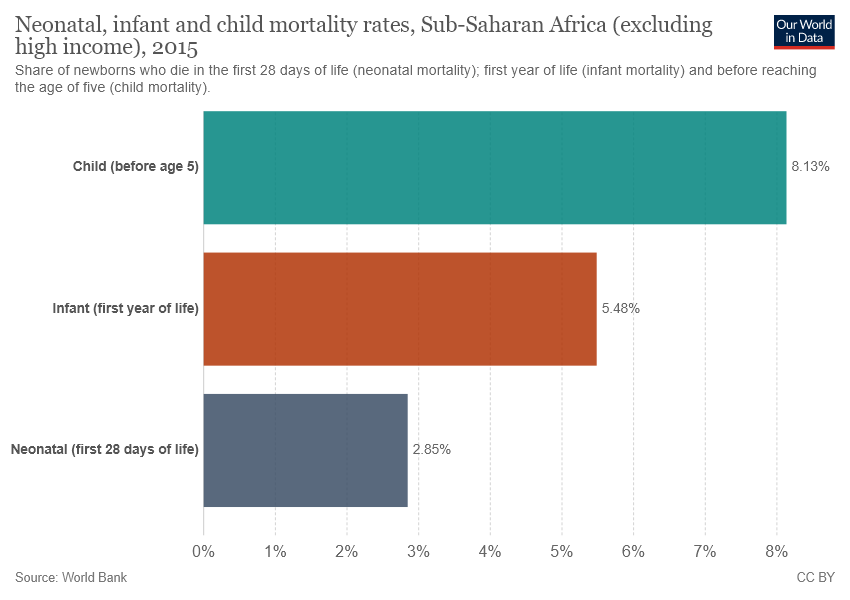Highlight a few significant elements in this photo. The value of Child bar is 8.13 